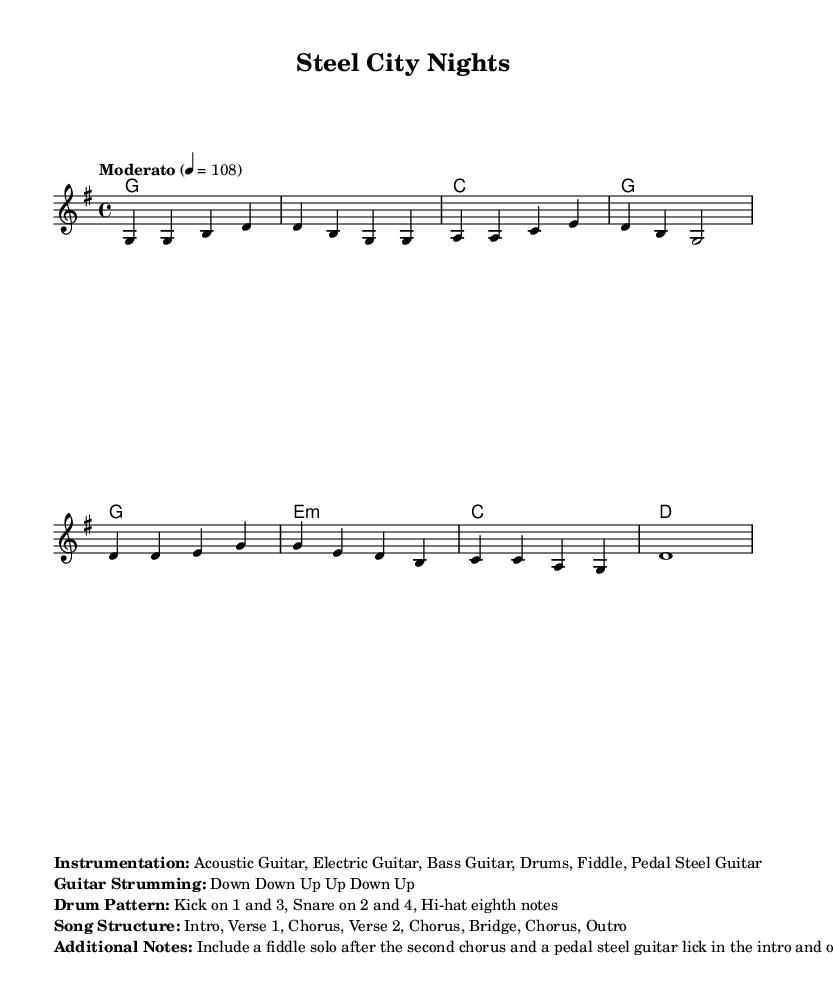What is the key signature of this music? The key signature is indicated by the absence of any sharps or flats, meaning it is in G major.
Answer: G major What is the time signature of the piece? The time signature is found in the beginning of the score and shows four beats per measure, indicated by 4/4.
Answer: 4/4 What is the tempo marking of the music? The tempo is noted at the beginning of the score as "Moderato," which indicates a moderate pace at 108 beats per minute.
Answer: Moderato 4 = 108 How many measures are in the chorus section? By counting the measures in the provided melody, the chorus has a total of four measures.
Answer: 4 What instruments are specified for this piece? The instrumentation is listed in the markup section, detailing the instruments required for performance including guitars and drums.
Answer: Acoustic Guitar, Electric Guitar, Bass Guitar, Drums, Fiddle, Pedal Steel Guitar What type of guitar strumming pattern is indicated? The strumming is written in the markup, showing a common pattern that includes down and up strokes. The specific pattern is: Down Down Up Up Down Up.
Answer: Down Down Up Up Down Up What additional musical element is included after the second chorus? The score notes the inclusion of a fiddle solo following the second chorus, which adds a distinct feature typical of country music.
Answer: Fiddle solo 